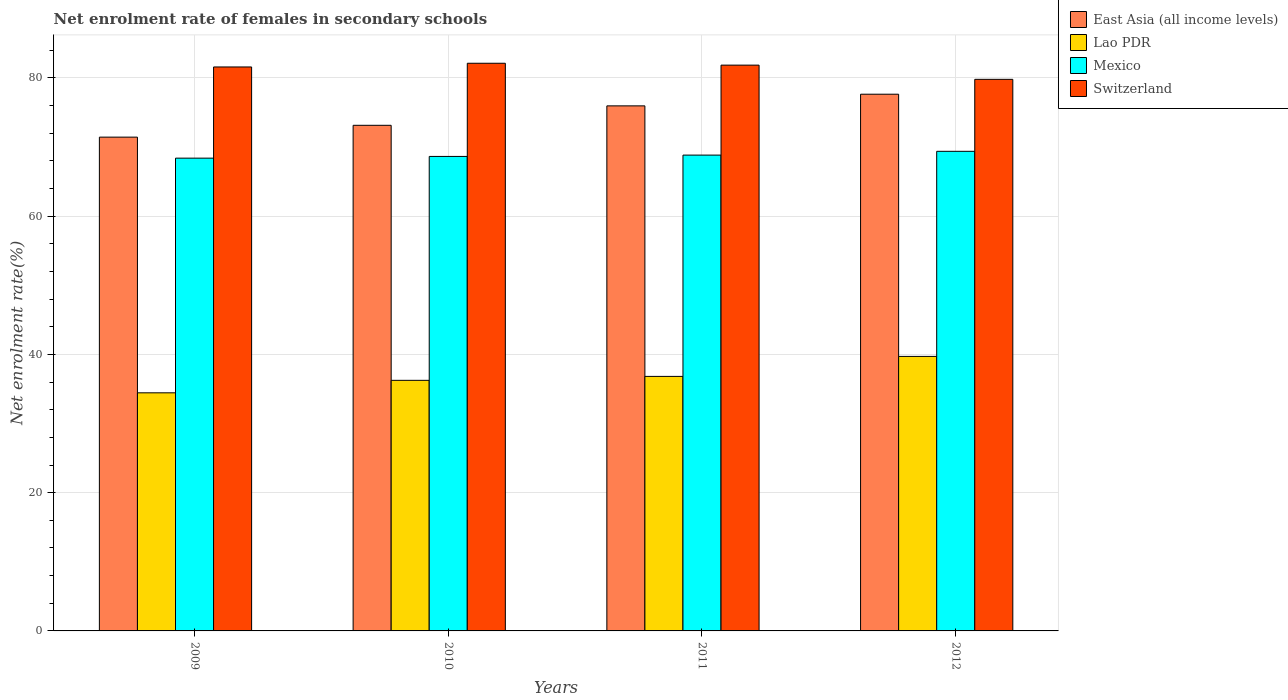How many different coloured bars are there?
Make the answer very short. 4. How many groups of bars are there?
Ensure brevity in your answer.  4. Are the number of bars per tick equal to the number of legend labels?
Provide a succinct answer. Yes. What is the label of the 3rd group of bars from the left?
Offer a very short reply. 2011. In how many cases, is the number of bars for a given year not equal to the number of legend labels?
Ensure brevity in your answer.  0. What is the net enrolment rate of females in secondary schools in East Asia (all income levels) in 2012?
Keep it short and to the point. 77.64. Across all years, what is the maximum net enrolment rate of females in secondary schools in Switzerland?
Keep it short and to the point. 82.12. Across all years, what is the minimum net enrolment rate of females in secondary schools in Switzerland?
Make the answer very short. 79.8. In which year was the net enrolment rate of females in secondary schools in East Asia (all income levels) minimum?
Your answer should be compact. 2009. What is the total net enrolment rate of females in secondary schools in Mexico in the graph?
Your answer should be compact. 275.26. What is the difference between the net enrolment rate of females in secondary schools in Switzerland in 2009 and that in 2012?
Your answer should be compact. 1.79. What is the difference between the net enrolment rate of females in secondary schools in Switzerland in 2010 and the net enrolment rate of females in secondary schools in East Asia (all income levels) in 2009?
Make the answer very short. 10.69. What is the average net enrolment rate of females in secondary schools in Switzerland per year?
Offer a terse response. 81.34. In the year 2009, what is the difference between the net enrolment rate of females in secondary schools in Mexico and net enrolment rate of females in secondary schools in Switzerland?
Provide a short and direct response. -13.19. What is the ratio of the net enrolment rate of females in secondary schools in Mexico in 2010 to that in 2012?
Keep it short and to the point. 0.99. What is the difference between the highest and the second highest net enrolment rate of females in secondary schools in Mexico?
Your response must be concise. 0.55. What is the difference between the highest and the lowest net enrolment rate of females in secondary schools in Lao PDR?
Ensure brevity in your answer.  5.27. Is it the case that in every year, the sum of the net enrolment rate of females in secondary schools in Mexico and net enrolment rate of females in secondary schools in East Asia (all income levels) is greater than the sum of net enrolment rate of females in secondary schools in Switzerland and net enrolment rate of females in secondary schools in Lao PDR?
Give a very brief answer. No. What does the 2nd bar from the left in 2010 represents?
Provide a short and direct response. Lao PDR. What does the 1st bar from the right in 2012 represents?
Your response must be concise. Switzerland. Is it the case that in every year, the sum of the net enrolment rate of females in secondary schools in Mexico and net enrolment rate of females in secondary schools in East Asia (all income levels) is greater than the net enrolment rate of females in secondary schools in Switzerland?
Ensure brevity in your answer.  Yes. How many bars are there?
Provide a succinct answer. 16. Are all the bars in the graph horizontal?
Provide a succinct answer. No. Are the values on the major ticks of Y-axis written in scientific E-notation?
Offer a terse response. No. Does the graph contain any zero values?
Offer a very short reply. No. How many legend labels are there?
Make the answer very short. 4. What is the title of the graph?
Provide a short and direct response. Net enrolment rate of females in secondary schools. What is the label or title of the Y-axis?
Give a very brief answer. Net enrolment rate(%). What is the Net enrolment rate(%) in East Asia (all income levels) in 2009?
Your response must be concise. 71.44. What is the Net enrolment rate(%) in Lao PDR in 2009?
Ensure brevity in your answer.  34.45. What is the Net enrolment rate(%) in Mexico in 2009?
Offer a terse response. 68.4. What is the Net enrolment rate(%) in Switzerland in 2009?
Provide a short and direct response. 81.59. What is the Net enrolment rate(%) in East Asia (all income levels) in 2010?
Your response must be concise. 73.15. What is the Net enrolment rate(%) in Lao PDR in 2010?
Make the answer very short. 36.25. What is the Net enrolment rate(%) in Mexico in 2010?
Offer a very short reply. 68.64. What is the Net enrolment rate(%) of Switzerland in 2010?
Give a very brief answer. 82.12. What is the Net enrolment rate(%) of East Asia (all income levels) in 2011?
Make the answer very short. 75.96. What is the Net enrolment rate(%) of Lao PDR in 2011?
Provide a short and direct response. 36.82. What is the Net enrolment rate(%) in Mexico in 2011?
Keep it short and to the point. 68.84. What is the Net enrolment rate(%) in Switzerland in 2011?
Provide a short and direct response. 81.85. What is the Net enrolment rate(%) of East Asia (all income levels) in 2012?
Your response must be concise. 77.64. What is the Net enrolment rate(%) in Lao PDR in 2012?
Offer a very short reply. 39.71. What is the Net enrolment rate(%) of Mexico in 2012?
Offer a very short reply. 69.38. What is the Net enrolment rate(%) in Switzerland in 2012?
Give a very brief answer. 79.8. Across all years, what is the maximum Net enrolment rate(%) in East Asia (all income levels)?
Ensure brevity in your answer.  77.64. Across all years, what is the maximum Net enrolment rate(%) of Lao PDR?
Make the answer very short. 39.71. Across all years, what is the maximum Net enrolment rate(%) of Mexico?
Provide a succinct answer. 69.38. Across all years, what is the maximum Net enrolment rate(%) of Switzerland?
Keep it short and to the point. 82.12. Across all years, what is the minimum Net enrolment rate(%) in East Asia (all income levels)?
Offer a terse response. 71.44. Across all years, what is the minimum Net enrolment rate(%) of Lao PDR?
Your answer should be very brief. 34.45. Across all years, what is the minimum Net enrolment rate(%) in Mexico?
Make the answer very short. 68.4. Across all years, what is the minimum Net enrolment rate(%) of Switzerland?
Your answer should be compact. 79.8. What is the total Net enrolment rate(%) in East Asia (all income levels) in the graph?
Offer a very short reply. 298.19. What is the total Net enrolment rate(%) in Lao PDR in the graph?
Keep it short and to the point. 147.23. What is the total Net enrolment rate(%) of Mexico in the graph?
Your answer should be compact. 275.26. What is the total Net enrolment rate(%) in Switzerland in the graph?
Your answer should be compact. 325.36. What is the difference between the Net enrolment rate(%) of East Asia (all income levels) in 2009 and that in 2010?
Provide a short and direct response. -1.71. What is the difference between the Net enrolment rate(%) in Lao PDR in 2009 and that in 2010?
Offer a terse response. -1.81. What is the difference between the Net enrolment rate(%) in Mexico in 2009 and that in 2010?
Offer a terse response. -0.25. What is the difference between the Net enrolment rate(%) of Switzerland in 2009 and that in 2010?
Provide a succinct answer. -0.54. What is the difference between the Net enrolment rate(%) in East Asia (all income levels) in 2009 and that in 2011?
Your answer should be compact. -4.52. What is the difference between the Net enrolment rate(%) in Lao PDR in 2009 and that in 2011?
Your answer should be compact. -2.37. What is the difference between the Net enrolment rate(%) in Mexico in 2009 and that in 2011?
Provide a succinct answer. -0.44. What is the difference between the Net enrolment rate(%) of Switzerland in 2009 and that in 2011?
Give a very brief answer. -0.26. What is the difference between the Net enrolment rate(%) in East Asia (all income levels) in 2009 and that in 2012?
Your answer should be compact. -6.21. What is the difference between the Net enrolment rate(%) in Lao PDR in 2009 and that in 2012?
Make the answer very short. -5.27. What is the difference between the Net enrolment rate(%) in Mexico in 2009 and that in 2012?
Your response must be concise. -0.99. What is the difference between the Net enrolment rate(%) of Switzerland in 2009 and that in 2012?
Your answer should be compact. 1.79. What is the difference between the Net enrolment rate(%) in East Asia (all income levels) in 2010 and that in 2011?
Make the answer very short. -2.81. What is the difference between the Net enrolment rate(%) of Lao PDR in 2010 and that in 2011?
Your answer should be very brief. -0.57. What is the difference between the Net enrolment rate(%) of Mexico in 2010 and that in 2011?
Provide a succinct answer. -0.19. What is the difference between the Net enrolment rate(%) of Switzerland in 2010 and that in 2011?
Keep it short and to the point. 0.27. What is the difference between the Net enrolment rate(%) in East Asia (all income levels) in 2010 and that in 2012?
Your answer should be very brief. -4.5. What is the difference between the Net enrolment rate(%) in Lao PDR in 2010 and that in 2012?
Your response must be concise. -3.46. What is the difference between the Net enrolment rate(%) in Mexico in 2010 and that in 2012?
Offer a very short reply. -0.74. What is the difference between the Net enrolment rate(%) in Switzerland in 2010 and that in 2012?
Make the answer very short. 2.33. What is the difference between the Net enrolment rate(%) in East Asia (all income levels) in 2011 and that in 2012?
Keep it short and to the point. -1.69. What is the difference between the Net enrolment rate(%) of Lao PDR in 2011 and that in 2012?
Your answer should be compact. -2.89. What is the difference between the Net enrolment rate(%) in Mexico in 2011 and that in 2012?
Offer a very short reply. -0.55. What is the difference between the Net enrolment rate(%) in Switzerland in 2011 and that in 2012?
Provide a short and direct response. 2.05. What is the difference between the Net enrolment rate(%) of East Asia (all income levels) in 2009 and the Net enrolment rate(%) of Lao PDR in 2010?
Offer a very short reply. 35.18. What is the difference between the Net enrolment rate(%) of East Asia (all income levels) in 2009 and the Net enrolment rate(%) of Mexico in 2010?
Your answer should be very brief. 2.79. What is the difference between the Net enrolment rate(%) of East Asia (all income levels) in 2009 and the Net enrolment rate(%) of Switzerland in 2010?
Your answer should be very brief. -10.69. What is the difference between the Net enrolment rate(%) in Lao PDR in 2009 and the Net enrolment rate(%) in Mexico in 2010?
Ensure brevity in your answer.  -34.2. What is the difference between the Net enrolment rate(%) in Lao PDR in 2009 and the Net enrolment rate(%) in Switzerland in 2010?
Your answer should be compact. -47.68. What is the difference between the Net enrolment rate(%) of Mexico in 2009 and the Net enrolment rate(%) of Switzerland in 2010?
Give a very brief answer. -13.73. What is the difference between the Net enrolment rate(%) of East Asia (all income levels) in 2009 and the Net enrolment rate(%) of Lao PDR in 2011?
Ensure brevity in your answer.  34.62. What is the difference between the Net enrolment rate(%) of East Asia (all income levels) in 2009 and the Net enrolment rate(%) of Mexico in 2011?
Your answer should be very brief. 2.6. What is the difference between the Net enrolment rate(%) in East Asia (all income levels) in 2009 and the Net enrolment rate(%) in Switzerland in 2011?
Keep it short and to the point. -10.41. What is the difference between the Net enrolment rate(%) of Lao PDR in 2009 and the Net enrolment rate(%) of Mexico in 2011?
Give a very brief answer. -34.39. What is the difference between the Net enrolment rate(%) in Lao PDR in 2009 and the Net enrolment rate(%) in Switzerland in 2011?
Give a very brief answer. -47.4. What is the difference between the Net enrolment rate(%) in Mexico in 2009 and the Net enrolment rate(%) in Switzerland in 2011?
Make the answer very short. -13.46. What is the difference between the Net enrolment rate(%) of East Asia (all income levels) in 2009 and the Net enrolment rate(%) of Lao PDR in 2012?
Your response must be concise. 31.72. What is the difference between the Net enrolment rate(%) of East Asia (all income levels) in 2009 and the Net enrolment rate(%) of Mexico in 2012?
Offer a very short reply. 2.05. What is the difference between the Net enrolment rate(%) of East Asia (all income levels) in 2009 and the Net enrolment rate(%) of Switzerland in 2012?
Keep it short and to the point. -8.36. What is the difference between the Net enrolment rate(%) of Lao PDR in 2009 and the Net enrolment rate(%) of Mexico in 2012?
Your response must be concise. -34.94. What is the difference between the Net enrolment rate(%) of Lao PDR in 2009 and the Net enrolment rate(%) of Switzerland in 2012?
Keep it short and to the point. -45.35. What is the difference between the Net enrolment rate(%) of Mexico in 2009 and the Net enrolment rate(%) of Switzerland in 2012?
Your answer should be very brief. -11.4. What is the difference between the Net enrolment rate(%) of East Asia (all income levels) in 2010 and the Net enrolment rate(%) of Lao PDR in 2011?
Offer a very short reply. 36.33. What is the difference between the Net enrolment rate(%) of East Asia (all income levels) in 2010 and the Net enrolment rate(%) of Mexico in 2011?
Give a very brief answer. 4.31. What is the difference between the Net enrolment rate(%) in East Asia (all income levels) in 2010 and the Net enrolment rate(%) in Switzerland in 2011?
Keep it short and to the point. -8.71. What is the difference between the Net enrolment rate(%) of Lao PDR in 2010 and the Net enrolment rate(%) of Mexico in 2011?
Make the answer very short. -32.58. What is the difference between the Net enrolment rate(%) of Lao PDR in 2010 and the Net enrolment rate(%) of Switzerland in 2011?
Provide a short and direct response. -45.6. What is the difference between the Net enrolment rate(%) in Mexico in 2010 and the Net enrolment rate(%) in Switzerland in 2011?
Give a very brief answer. -13.21. What is the difference between the Net enrolment rate(%) in East Asia (all income levels) in 2010 and the Net enrolment rate(%) in Lao PDR in 2012?
Keep it short and to the point. 33.43. What is the difference between the Net enrolment rate(%) of East Asia (all income levels) in 2010 and the Net enrolment rate(%) of Mexico in 2012?
Provide a succinct answer. 3.76. What is the difference between the Net enrolment rate(%) in East Asia (all income levels) in 2010 and the Net enrolment rate(%) in Switzerland in 2012?
Offer a very short reply. -6.65. What is the difference between the Net enrolment rate(%) in Lao PDR in 2010 and the Net enrolment rate(%) in Mexico in 2012?
Your answer should be compact. -33.13. What is the difference between the Net enrolment rate(%) in Lao PDR in 2010 and the Net enrolment rate(%) in Switzerland in 2012?
Keep it short and to the point. -43.54. What is the difference between the Net enrolment rate(%) of Mexico in 2010 and the Net enrolment rate(%) of Switzerland in 2012?
Provide a succinct answer. -11.15. What is the difference between the Net enrolment rate(%) in East Asia (all income levels) in 2011 and the Net enrolment rate(%) in Lao PDR in 2012?
Provide a short and direct response. 36.25. What is the difference between the Net enrolment rate(%) of East Asia (all income levels) in 2011 and the Net enrolment rate(%) of Mexico in 2012?
Offer a terse response. 6.58. What is the difference between the Net enrolment rate(%) of East Asia (all income levels) in 2011 and the Net enrolment rate(%) of Switzerland in 2012?
Offer a very short reply. -3.84. What is the difference between the Net enrolment rate(%) in Lao PDR in 2011 and the Net enrolment rate(%) in Mexico in 2012?
Your answer should be compact. -32.56. What is the difference between the Net enrolment rate(%) in Lao PDR in 2011 and the Net enrolment rate(%) in Switzerland in 2012?
Ensure brevity in your answer.  -42.98. What is the difference between the Net enrolment rate(%) of Mexico in 2011 and the Net enrolment rate(%) of Switzerland in 2012?
Make the answer very short. -10.96. What is the average Net enrolment rate(%) in East Asia (all income levels) per year?
Give a very brief answer. 74.55. What is the average Net enrolment rate(%) in Lao PDR per year?
Give a very brief answer. 36.81. What is the average Net enrolment rate(%) of Mexico per year?
Provide a short and direct response. 68.81. What is the average Net enrolment rate(%) of Switzerland per year?
Offer a terse response. 81.34. In the year 2009, what is the difference between the Net enrolment rate(%) in East Asia (all income levels) and Net enrolment rate(%) in Lao PDR?
Keep it short and to the point. 36.99. In the year 2009, what is the difference between the Net enrolment rate(%) of East Asia (all income levels) and Net enrolment rate(%) of Mexico?
Your response must be concise. 3.04. In the year 2009, what is the difference between the Net enrolment rate(%) in East Asia (all income levels) and Net enrolment rate(%) in Switzerland?
Your answer should be compact. -10.15. In the year 2009, what is the difference between the Net enrolment rate(%) in Lao PDR and Net enrolment rate(%) in Mexico?
Keep it short and to the point. -33.95. In the year 2009, what is the difference between the Net enrolment rate(%) of Lao PDR and Net enrolment rate(%) of Switzerland?
Make the answer very short. -47.14. In the year 2009, what is the difference between the Net enrolment rate(%) in Mexico and Net enrolment rate(%) in Switzerland?
Your answer should be compact. -13.19. In the year 2010, what is the difference between the Net enrolment rate(%) of East Asia (all income levels) and Net enrolment rate(%) of Lao PDR?
Your answer should be very brief. 36.89. In the year 2010, what is the difference between the Net enrolment rate(%) in East Asia (all income levels) and Net enrolment rate(%) in Mexico?
Your answer should be compact. 4.5. In the year 2010, what is the difference between the Net enrolment rate(%) in East Asia (all income levels) and Net enrolment rate(%) in Switzerland?
Give a very brief answer. -8.98. In the year 2010, what is the difference between the Net enrolment rate(%) in Lao PDR and Net enrolment rate(%) in Mexico?
Give a very brief answer. -32.39. In the year 2010, what is the difference between the Net enrolment rate(%) in Lao PDR and Net enrolment rate(%) in Switzerland?
Provide a succinct answer. -45.87. In the year 2010, what is the difference between the Net enrolment rate(%) in Mexico and Net enrolment rate(%) in Switzerland?
Give a very brief answer. -13.48. In the year 2011, what is the difference between the Net enrolment rate(%) of East Asia (all income levels) and Net enrolment rate(%) of Lao PDR?
Keep it short and to the point. 39.14. In the year 2011, what is the difference between the Net enrolment rate(%) in East Asia (all income levels) and Net enrolment rate(%) in Mexico?
Your answer should be very brief. 7.12. In the year 2011, what is the difference between the Net enrolment rate(%) of East Asia (all income levels) and Net enrolment rate(%) of Switzerland?
Your answer should be compact. -5.89. In the year 2011, what is the difference between the Net enrolment rate(%) of Lao PDR and Net enrolment rate(%) of Mexico?
Your answer should be compact. -32.02. In the year 2011, what is the difference between the Net enrolment rate(%) of Lao PDR and Net enrolment rate(%) of Switzerland?
Offer a terse response. -45.03. In the year 2011, what is the difference between the Net enrolment rate(%) in Mexico and Net enrolment rate(%) in Switzerland?
Provide a short and direct response. -13.01. In the year 2012, what is the difference between the Net enrolment rate(%) of East Asia (all income levels) and Net enrolment rate(%) of Lao PDR?
Make the answer very short. 37.93. In the year 2012, what is the difference between the Net enrolment rate(%) in East Asia (all income levels) and Net enrolment rate(%) in Mexico?
Keep it short and to the point. 8.26. In the year 2012, what is the difference between the Net enrolment rate(%) in East Asia (all income levels) and Net enrolment rate(%) in Switzerland?
Provide a succinct answer. -2.15. In the year 2012, what is the difference between the Net enrolment rate(%) in Lao PDR and Net enrolment rate(%) in Mexico?
Ensure brevity in your answer.  -29.67. In the year 2012, what is the difference between the Net enrolment rate(%) of Lao PDR and Net enrolment rate(%) of Switzerland?
Make the answer very short. -40.08. In the year 2012, what is the difference between the Net enrolment rate(%) of Mexico and Net enrolment rate(%) of Switzerland?
Offer a terse response. -10.41. What is the ratio of the Net enrolment rate(%) of East Asia (all income levels) in 2009 to that in 2010?
Offer a terse response. 0.98. What is the ratio of the Net enrolment rate(%) in Lao PDR in 2009 to that in 2010?
Offer a very short reply. 0.95. What is the ratio of the Net enrolment rate(%) in Mexico in 2009 to that in 2010?
Give a very brief answer. 1. What is the ratio of the Net enrolment rate(%) in East Asia (all income levels) in 2009 to that in 2011?
Provide a succinct answer. 0.94. What is the ratio of the Net enrolment rate(%) in Lao PDR in 2009 to that in 2011?
Give a very brief answer. 0.94. What is the ratio of the Net enrolment rate(%) in East Asia (all income levels) in 2009 to that in 2012?
Keep it short and to the point. 0.92. What is the ratio of the Net enrolment rate(%) of Lao PDR in 2009 to that in 2012?
Offer a very short reply. 0.87. What is the ratio of the Net enrolment rate(%) of Mexico in 2009 to that in 2012?
Give a very brief answer. 0.99. What is the ratio of the Net enrolment rate(%) in Switzerland in 2009 to that in 2012?
Provide a short and direct response. 1.02. What is the ratio of the Net enrolment rate(%) of Lao PDR in 2010 to that in 2011?
Offer a very short reply. 0.98. What is the ratio of the Net enrolment rate(%) in East Asia (all income levels) in 2010 to that in 2012?
Your answer should be compact. 0.94. What is the ratio of the Net enrolment rate(%) in Lao PDR in 2010 to that in 2012?
Provide a succinct answer. 0.91. What is the ratio of the Net enrolment rate(%) of Mexico in 2010 to that in 2012?
Your answer should be very brief. 0.99. What is the ratio of the Net enrolment rate(%) of Switzerland in 2010 to that in 2012?
Your response must be concise. 1.03. What is the ratio of the Net enrolment rate(%) of East Asia (all income levels) in 2011 to that in 2012?
Offer a terse response. 0.98. What is the ratio of the Net enrolment rate(%) in Lao PDR in 2011 to that in 2012?
Provide a short and direct response. 0.93. What is the ratio of the Net enrolment rate(%) of Switzerland in 2011 to that in 2012?
Give a very brief answer. 1.03. What is the difference between the highest and the second highest Net enrolment rate(%) of East Asia (all income levels)?
Provide a short and direct response. 1.69. What is the difference between the highest and the second highest Net enrolment rate(%) in Lao PDR?
Your answer should be very brief. 2.89. What is the difference between the highest and the second highest Net enrolment rate(%) in Mexico?
Give a very brief answer. 0.55. What is the difference between the highest and the second highest Net enrolment rate(%) of Switzerland?
Provide a short and direct response. 0.27. What is the difference between the highest and the lowest Net enrolment rate(%) in East Asia (all income levels)?
Your response must be concise. 6.21. What is the difference between the highest and the lowest Net enrolment rate(%) of Lao PDR?
Ensure brevity in your answer.  5.27. What is the difference between the highest and the lowest Net enrolment rate(%) of Mexico?
Provide a succinct answer. 0.99. What is the difference between the highest and the lowest Net enrolment rate(%) in Switzerland?
Your answer should be very brief. 2.33. 